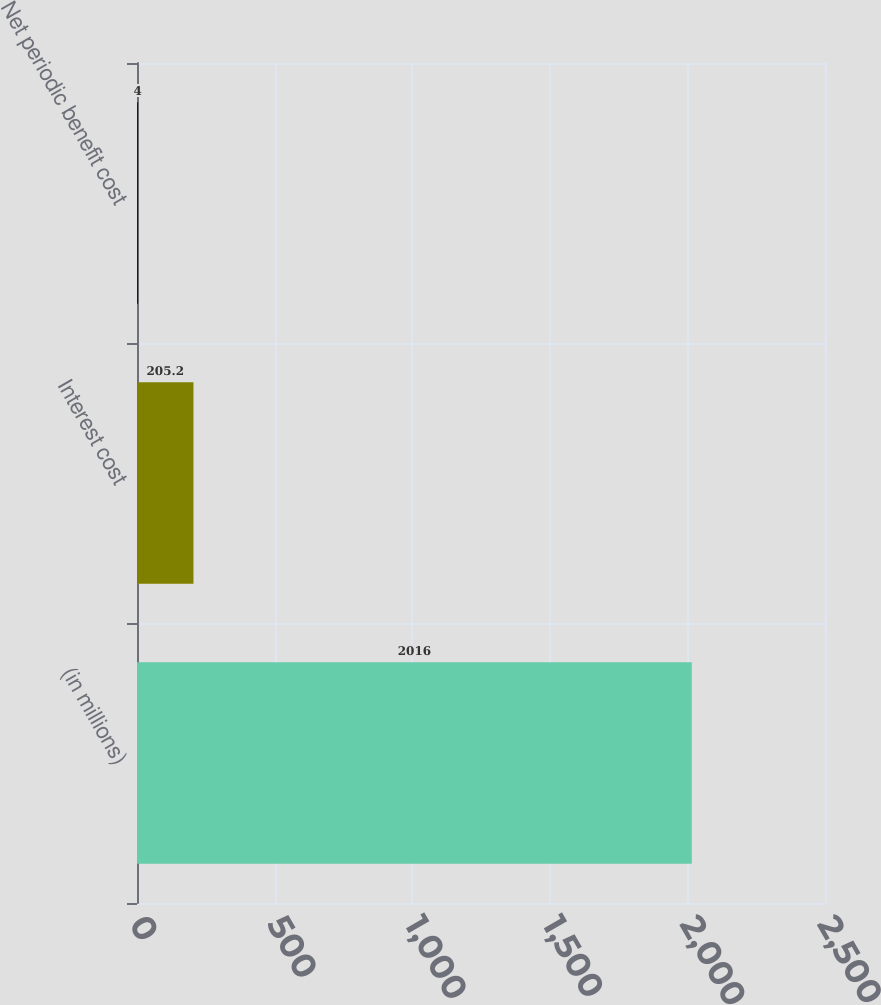<chart> <loc_0><loc_0><loc_500><loc_500><bar_chart><fcel>(in millions)<fcel>Interest cost<fcel>Net periodic benefit cost<nl><fcel>2016<fcel>205.2<fcel>4<nl></chart> 